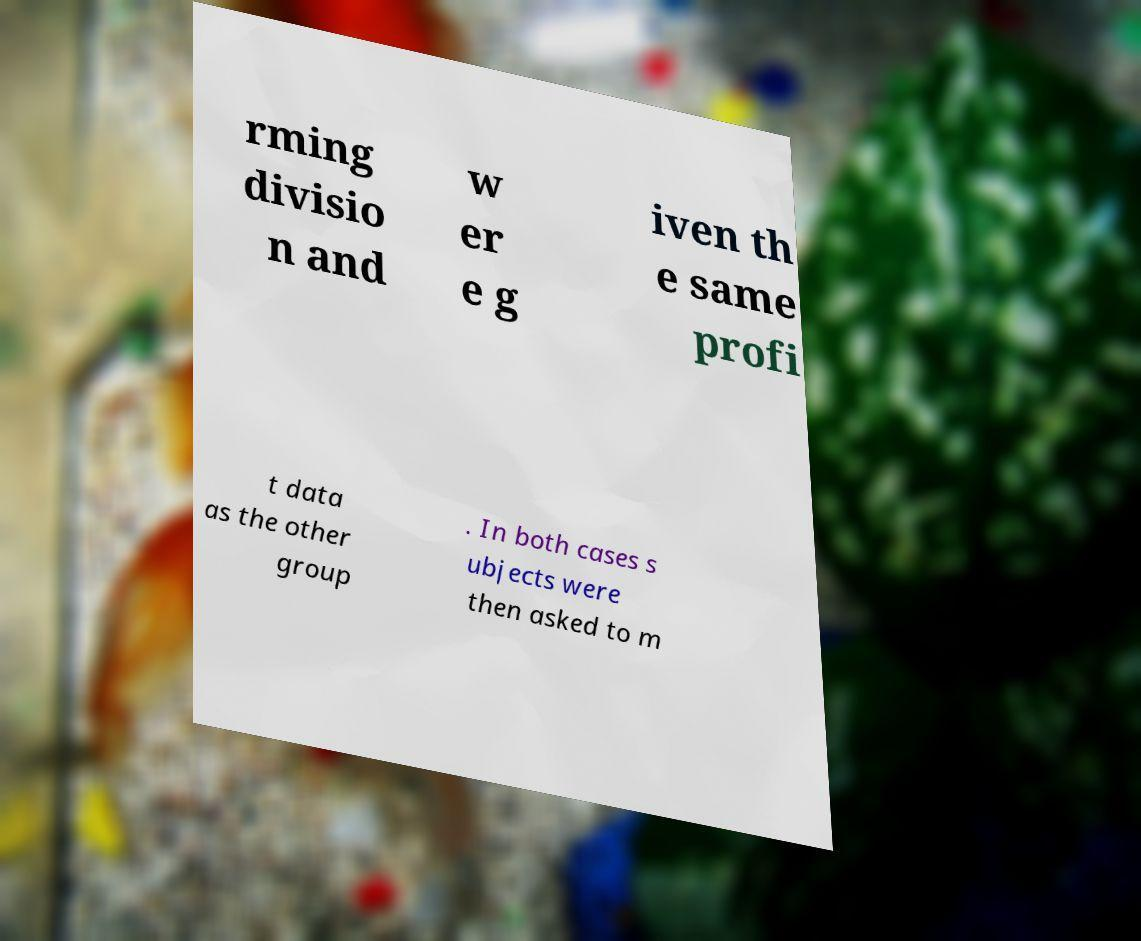Can you read and provide the text displayed in the image?This photo seems to have some interesting text. Can you extract and type it out for me? rming divisio n and w er e g iven th e same profi t data as the other group . In both cases s ubjects were then asked to m 